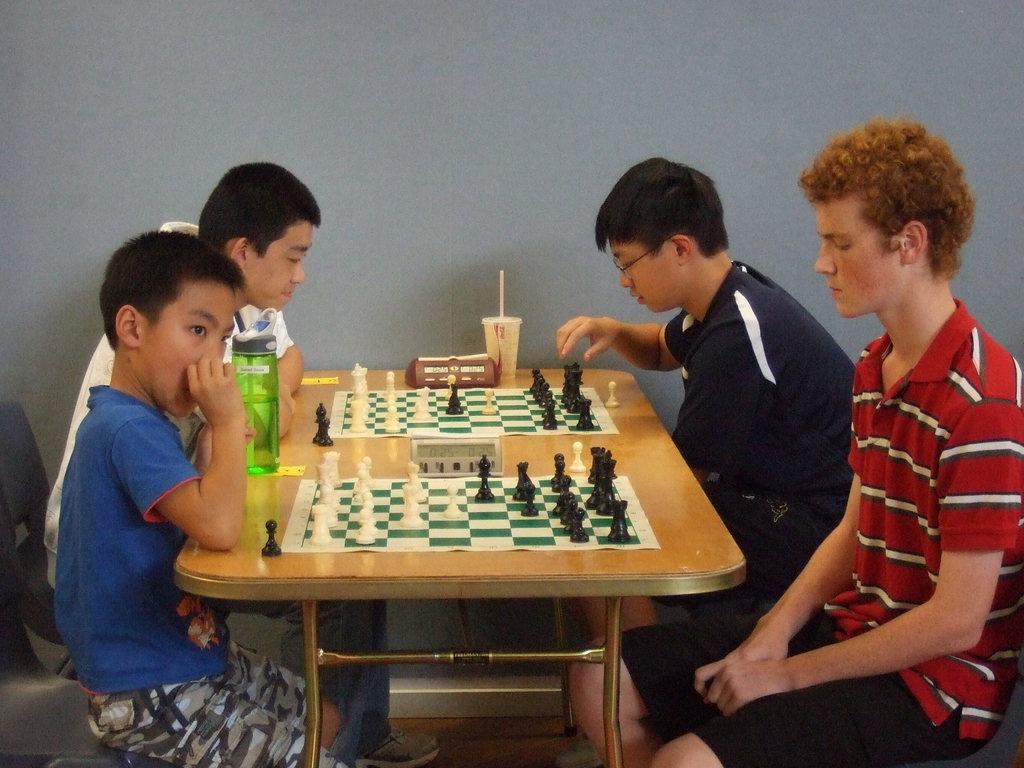In one or two sentences, can you explain what this image depicts? This image contains four person. Person at the right side is wearing red shirt behind person is wearing a blue shirt. At the left side there is a person wearing blue shirt behind person is wearing white shirt. There is a bottle and chess board coins arranged on a table. 